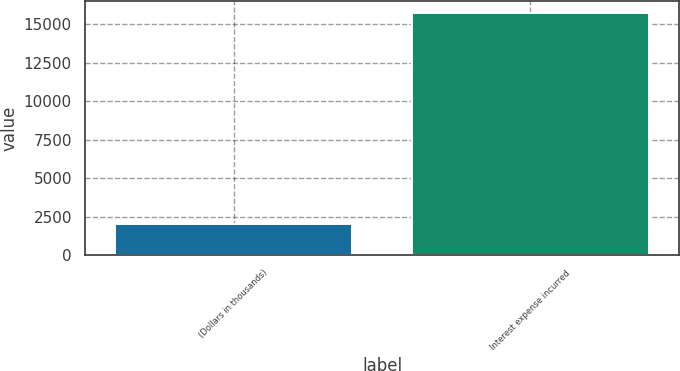<chart> <loc_0><loc_0><loc_500><loc_500><bar_chart><fcel>(Dollars in thousands)<fcel>Interest expense incurred<nl><fcel>2010<fcel>15748<nl></chart> 